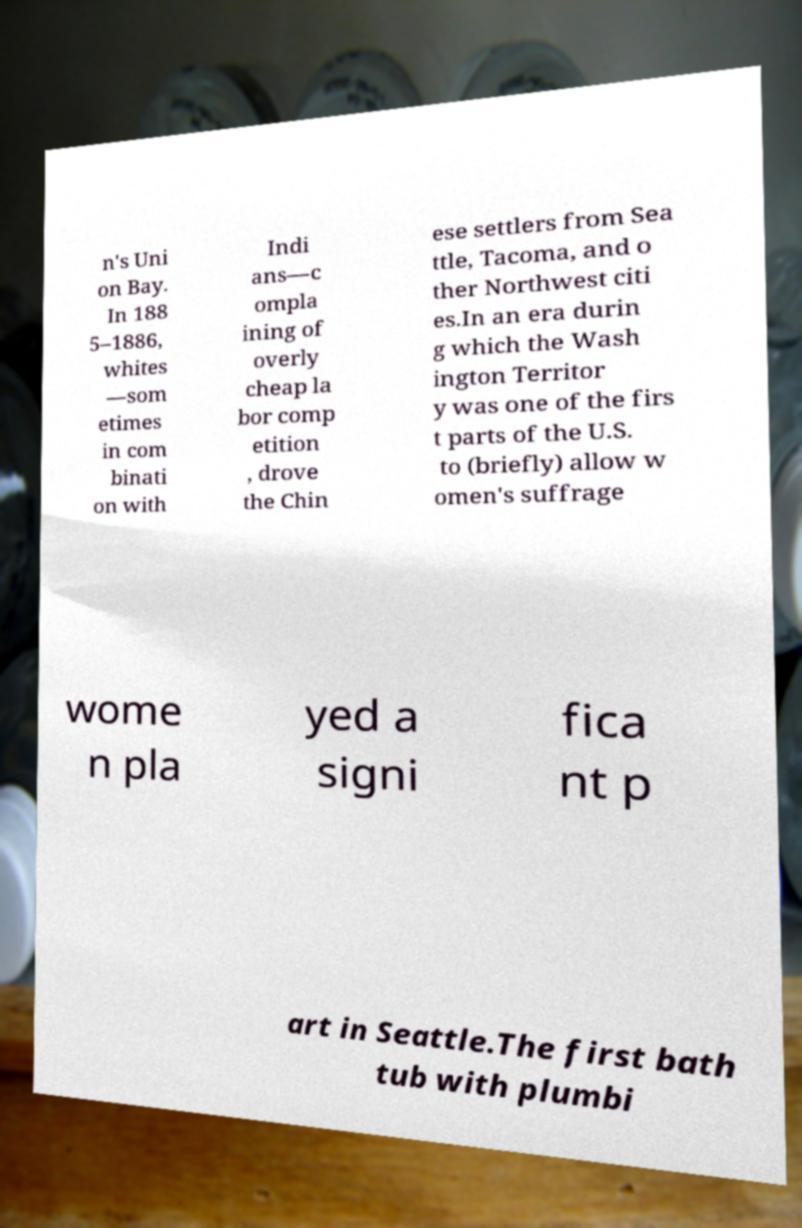For documentation purposes, I need the text within this image transcribed. Could you provide that? n's Uni on Bay. In 188 5–1886, whites —som etimes in com binati on with Indi ans—c ompla ining of overly cheap la bor comp etition , drove the Chin ese settlers from Sea ttle, Tacoma, and o ther Northwest citi es.In an era durin g which the Wash ington Territor y was one of the firs t parts of the U.S. to (briefly) allow w omen's suffrage wome n pla yed a signi fica nt p art in Seattle.The first bath tub with plumbi 